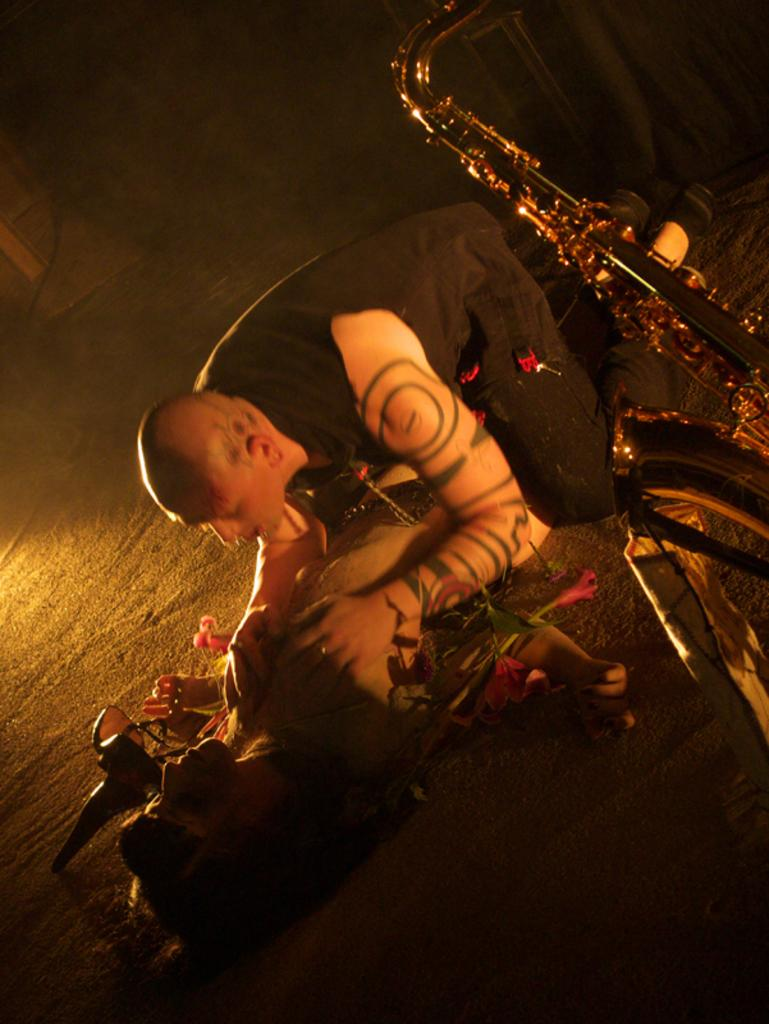How many people are in the image? There are two people in the image. What is the position of one person in relation to the other? One person is lying on the floor, and the other person is above the person lying on the floor. What object related to music can be seen in the image? There is a musical instrument in the image. How many sheep are visible in the image? There are no sheep present in the image. What type of wish can be granted by the person lying on the floor? The image does not depict any wishes or granting of wishes. 